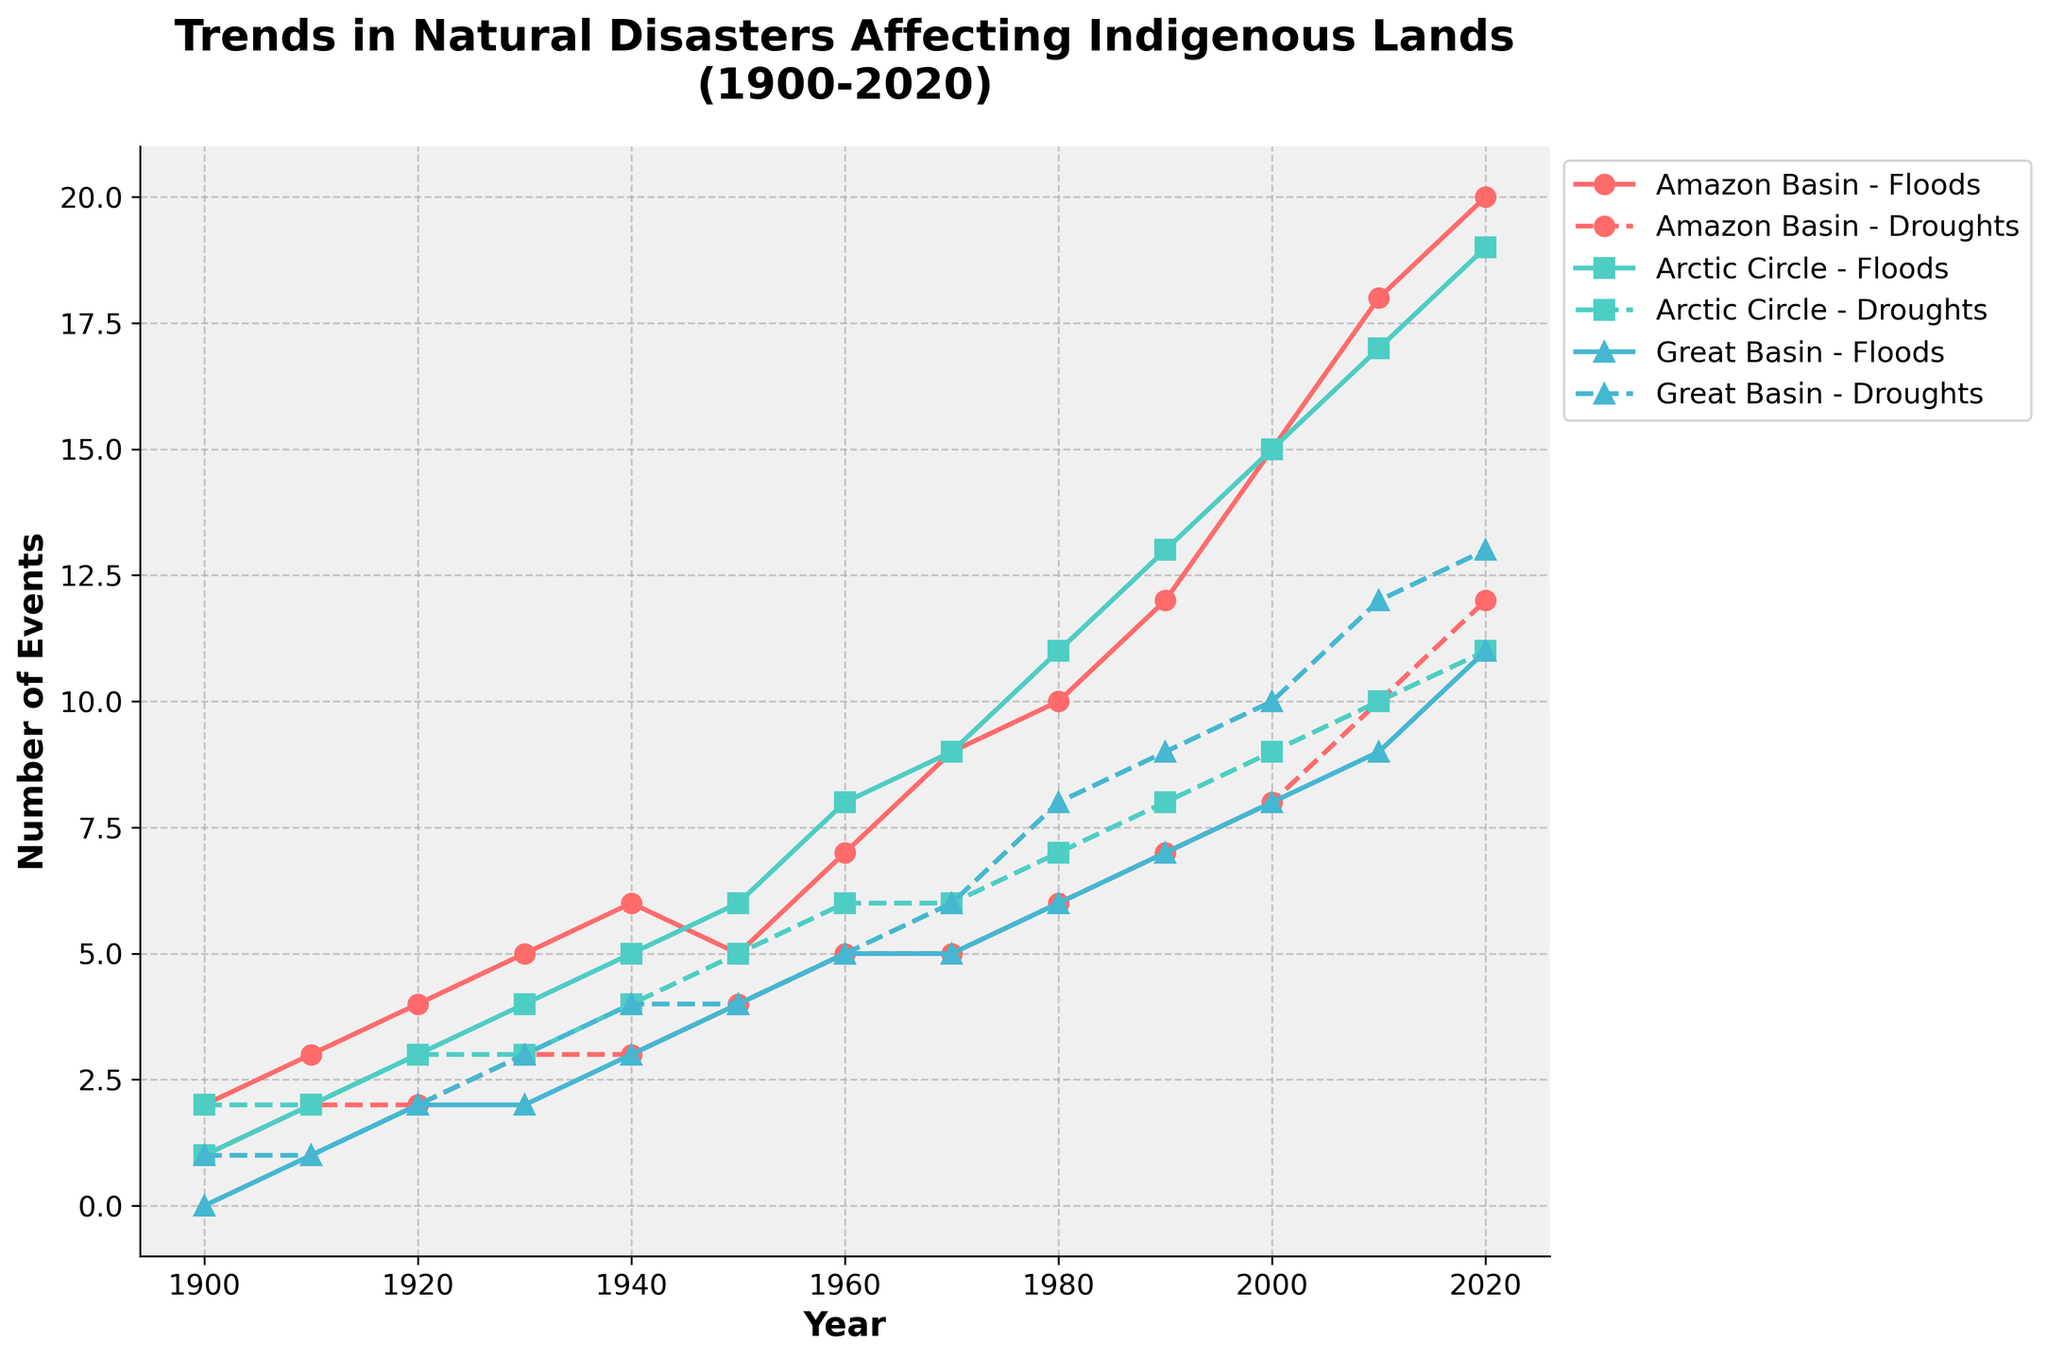What is the title of the plot? The title of the plot is at the top of the figure. It reads "Trends in Natural Disasters Affecting Indigenous Lands (1900-2020)."
Answer: Trends in Natural Disasters Affecting Indigenous Lands (1900-2020) Which region experienced the highest number of flood events in 2020? To determine the region with the highest number of flood events in 2020, look at the data points for each region at the year 2020. The Amazon Basin shows the highest flood events at 20.
Answer: Amazon Basin How many drought events did the Great Basin experience in 2010? Locate the data point for the Great Basin region corresponding to the year 2010. From the plot, it shows 12 drought events.
Answer: 12 Compare the trend of flood events in the Arctic Circle from 1900 to 2020. Is it increasing, decreasing, or constant? Observe the data points of flood events in the Arctic Circle over time. The trend shows a consistent increase in flood events from 1900 (1 event) to 2020 (19 events).
Answer: Increasing What is the difference in the number of flood events between the Amazon Basin and the Arctic Circle in 1950? First, identify the number of flood events for both regions in the year 1950. The Amazon Basin had 5 flood events, while the Arctic Circle had 6 flood events. Then, calculate the difference: 6 - 5 = 1.
Answer: 1 Which region had fewer drought events in 1940, the Amazon Basin or the Great Basin? Check the drought events for both regions in 1940. The Amazon Basin had 3 drought events, and the Great Basin had 4 drought events. Therefore, the Amazon Basin had fewer.
Answer: Amazon Basin How many total flood events did the Arctic Circle and Great Basin experience combined in 2020? Add the number of flood events in both the Arctic Circle (19) and the Great Basin (11) in 2020. The total is 19 + 11 = 30.
Answer: 30 During which decade did the Amazon Basin see the most significant increase in flood events? Compare the increments in flood events for each decade for the Amazon Basin. The largest increment is from 1940 (6 events) to 1950 (5 events), where the change was -1 flood events. The biggest increase in flood events happened between 1990 (12 events) and 2000 (15 events) with an increase of 3 events.
Answer: 1990-2000 What is the average number of drought events in the Great Basin over the entire time period? Calculate the sum of drought events in the Great Basin from 1900 to 2020 and divide by the number of years (13 data points). Sum: 1+1+2+3+4+4+5+6+8+9+10+12+13 = 78. The average is 78/13 ≈ 6.
Answer: 6 